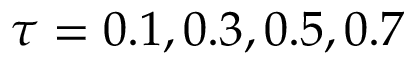<formula> <loc_0><loc_0><loc_500><loc_500>\tau = 0 . 1 , 0 . 3 , 0 . 5 , 0 . 7</formula> 